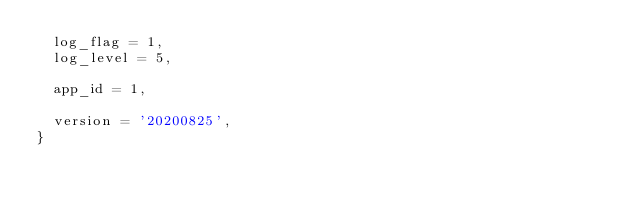Convert code to text. <code><loc_0><loc_0><loc_500><loc_500><_Lua_>  log_flag = 1,
  log_level = 5,

  app_id = 1,

  version = '20200825',
}
</code> 